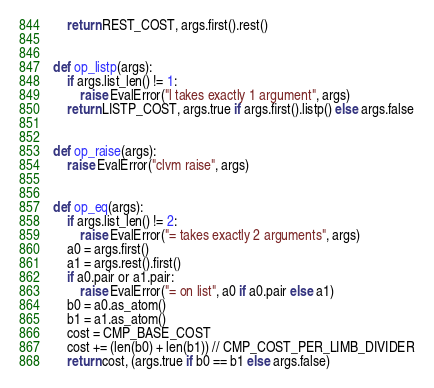Convert code to text. <code><loc_0><loc_0><loc_500><loc_500><_Python_>    return REST_COST, args.first().rest()


def op_listp(args):
    if args.list_len() != 1:
        raise EvalError("l takes exactly 1 argument", args)
    return LISTP_COST, args.true if args.first().listp() else args.false


def op_raise(args):
    raise EvalError("clvm raise", args)


def op_eq(args):
    if args.list_len() != 2:
        raise EvalError("= takes exactly 2 arguments", args)
    a0 = args.first()
    a1 = args.rest().first()
    if a0.pair or a1.pair:
        raise EvalError("= on list", a0 if a0.pair else a1)
    b0 = a0.as_atom()
    b1 = a1.as_atom()
    cost = CMP_BASE_COST
    cost += (len(b0) + len(b1)) // CMP_COST_PER_LIMB_DIVIDER
    return cost, (args.true if b0 == b1 else args.false)
</code> 